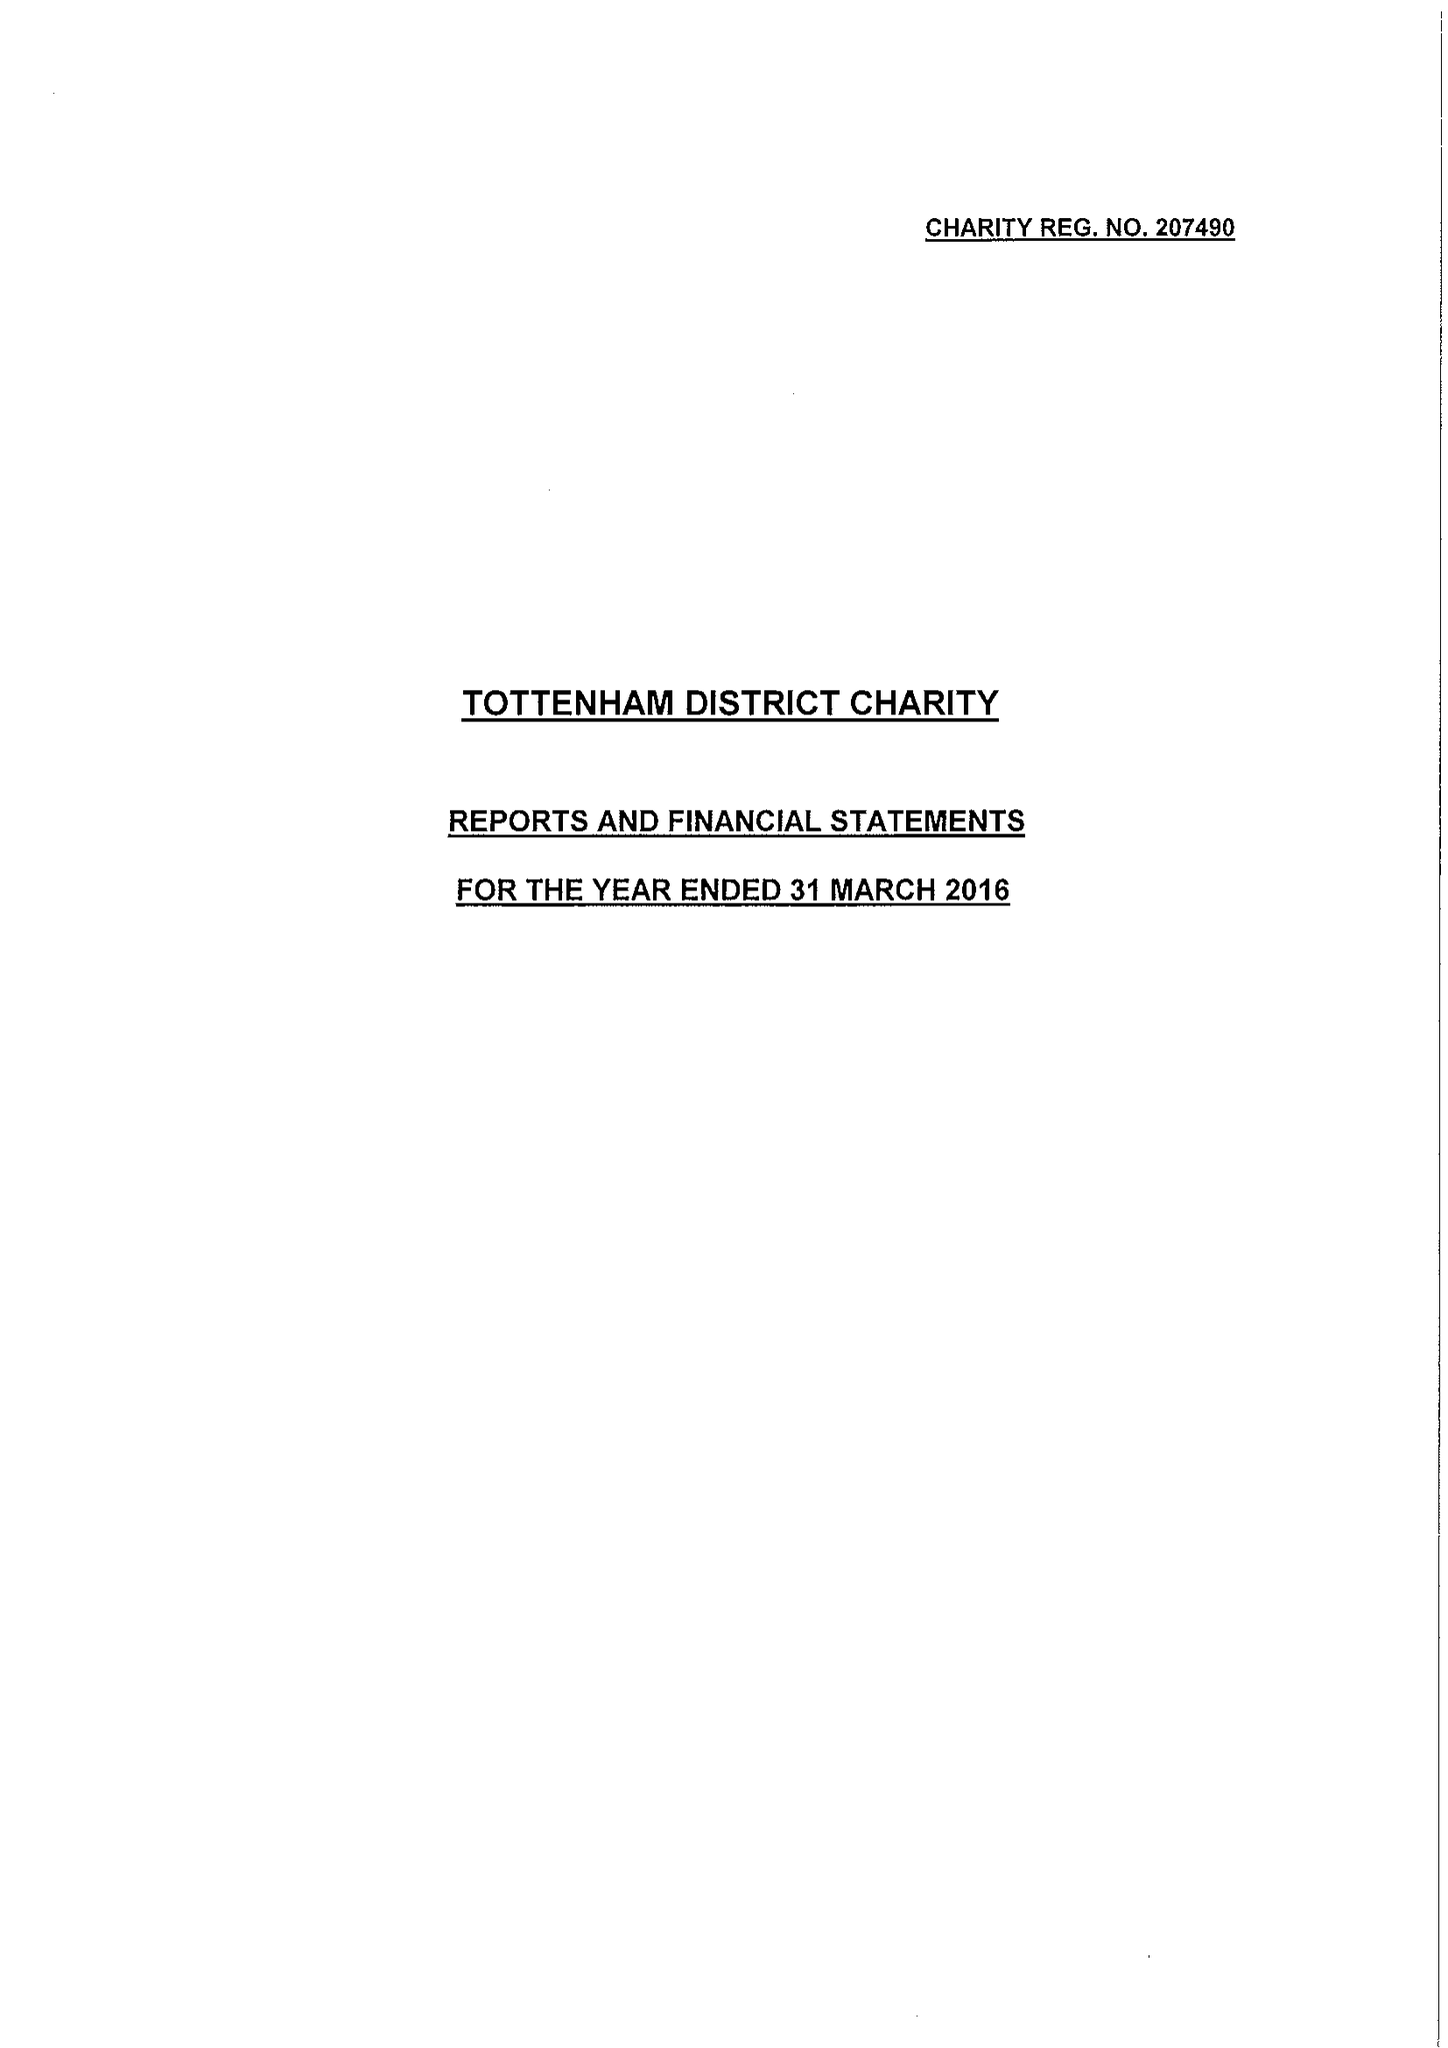What is the value for the charity_name?
Answer the question using a single word or phrase. Tottenham District Charity 